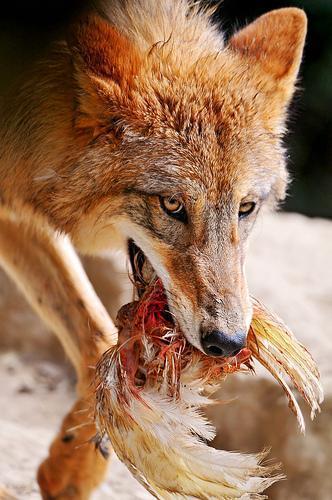How many wolves are there?
Give a very brief answer. 1. How many eyes does the wolf have open?
Give a very brief answer. 2. How many of the wolf's paws are visible?
Give a very brief answer. 1. 